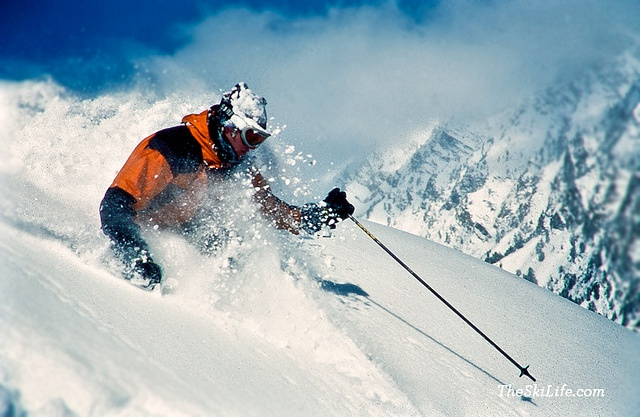Describe the objects in this image and their specific colors. I can see people in navy, black, darkgray, gray, and lightgray tones in this image. 